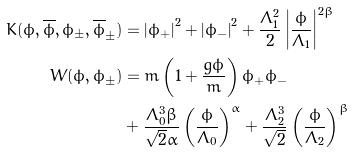Convert formula to latex. <formula><loc_0><loc_0><loc_500><loc_500>K ( \phi , \overline { \phi } , \phi _ { \pm } , \overline { \phi } _ { \pm } ) & = \left | \phi _ { + } \right | ^ { 2 } + \left | \phi _ { - } \right | ^ { 2 } + \frac { \Lambda _ { 1 } ^ { 2 } } { 2 } \left | \frac { \phi } { \Lambda _ { 1 } } \right | ^ { 2 \beta } \\ W ( \phi , \phi _ { \pm } ) & = m \left ( 1 + \frac { g \phi } { m } \right ) \phi _ { + } \phi _ { - } \\ & + \frac { \Lambda _ { 0 } ^ { 3 } \beta } { \sqrt { 2 } \alpha } \left ( \frac { \phi } { \Lambda _ { 0 } } \right ) ^ { \alpha } + \frac { \Lambda _ { 2 } ^ { 3 } } { \sqrt { 2 } } \left ( \frac { \phi } { \Lambda _ { 2 } } \right ) ^ { \beta }</formula> 